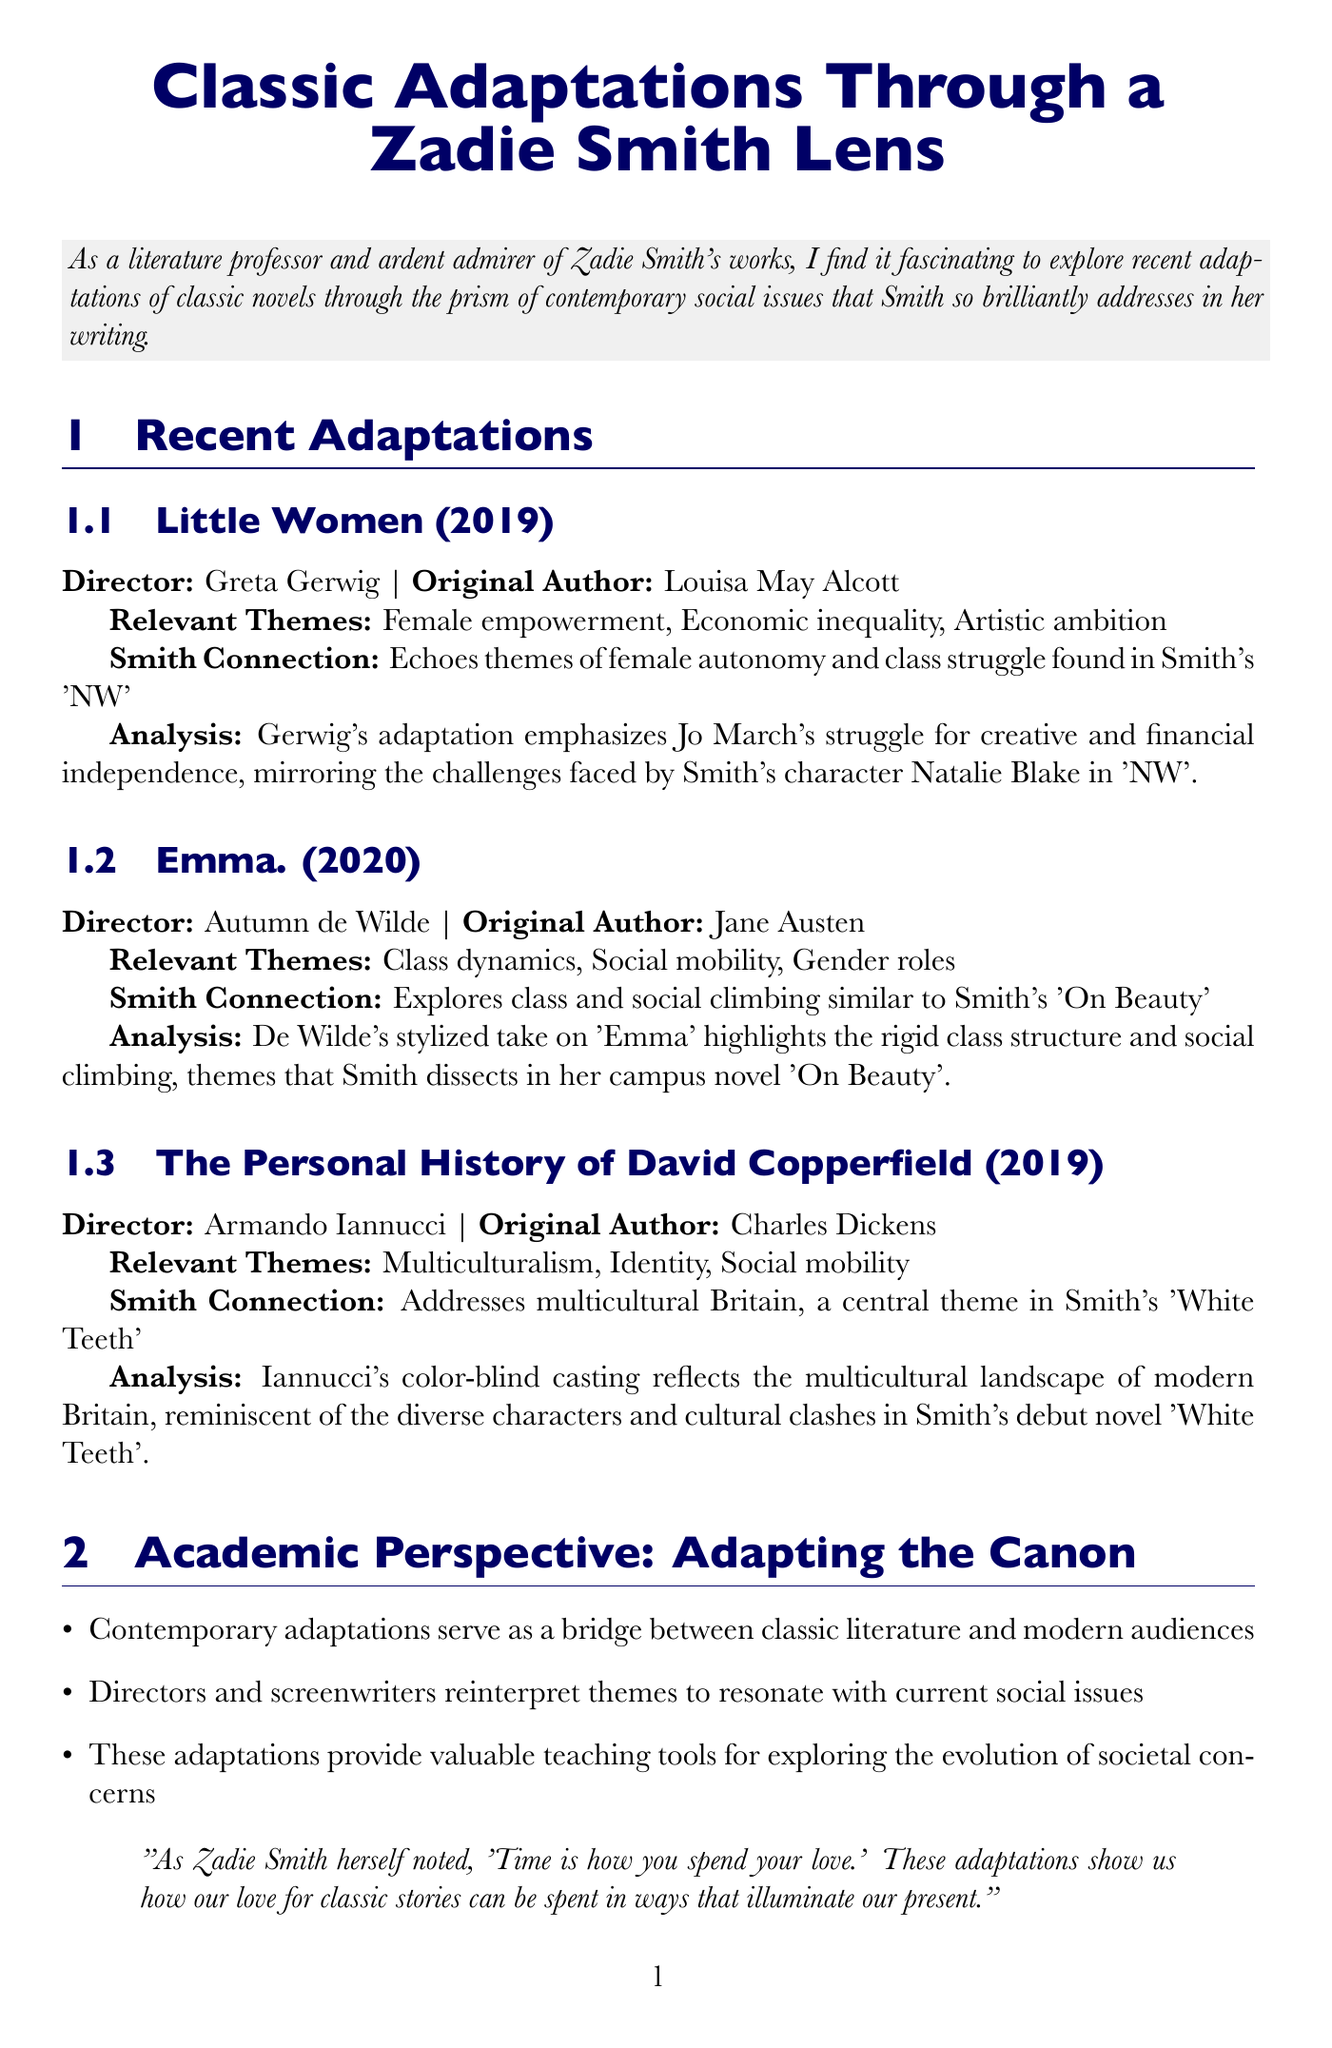What is the title of the newsletter? The title of the newsletter is provided in the document's heading.
Answer: Classic Adaptations Through a Zadie Smith Lens Who directed "Little Women"? The director's name is mentioned in the section on "Little Women".
Answer: Greta Gerwig What year was "Emma." released? The release year is stated in the "Emma." adaptation section.
Answer: 2020 Which classic novel is associated with themes of multiculturalism? The relevant theme is linked to the adaptation of "The Personal History of David Copperfield".
Answer: The Personal History of David Copperfield What is one of the key points in the academic perspective? The key points list in the academic section provides various insights.
Answer: Contemporary adaptations serve as a bridge between classic literature and modern audiences How many related works of Zadie Smith are listed? The document mentions the number of Smith's works in the related section.
Answer: Three What theme is explored in "On Beauty"? The specific theme associated with "On Beauty" is highlighted in the related section.
Answer: Academic life, race, and class What adaptation reflects themes of female empowerment? The adaptation mentioned in the document is cited with this theme.
Answer: Little Women Who is the original author of "David Copperfield"? The author's name is given in the section about the adaptation.
Answer: Charles Dickens 